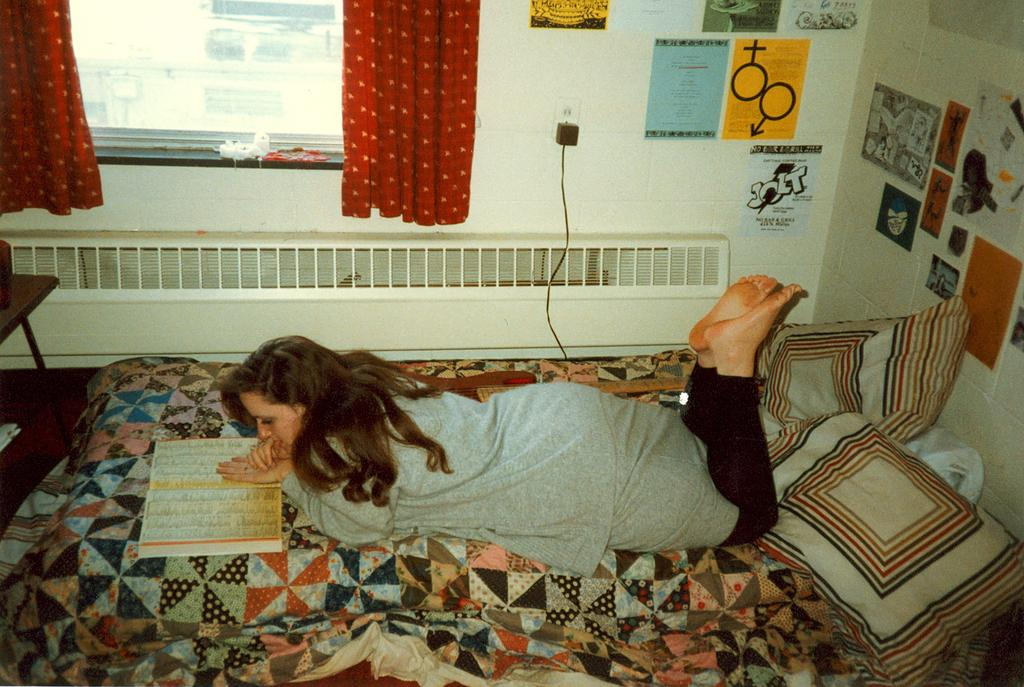What is the woman doing in the image? The woman is lying on a bed in the image. What is present on the bed besides the woman? There are two pillows on the bed. What can be seen in the background of the image? There are posts visible on the wall in the background of the image. What type of bomb is being tested in the image? There is no bomb or testing activity present in the image; it features a woman lying on a bed with pillows and posts visible in the background. 